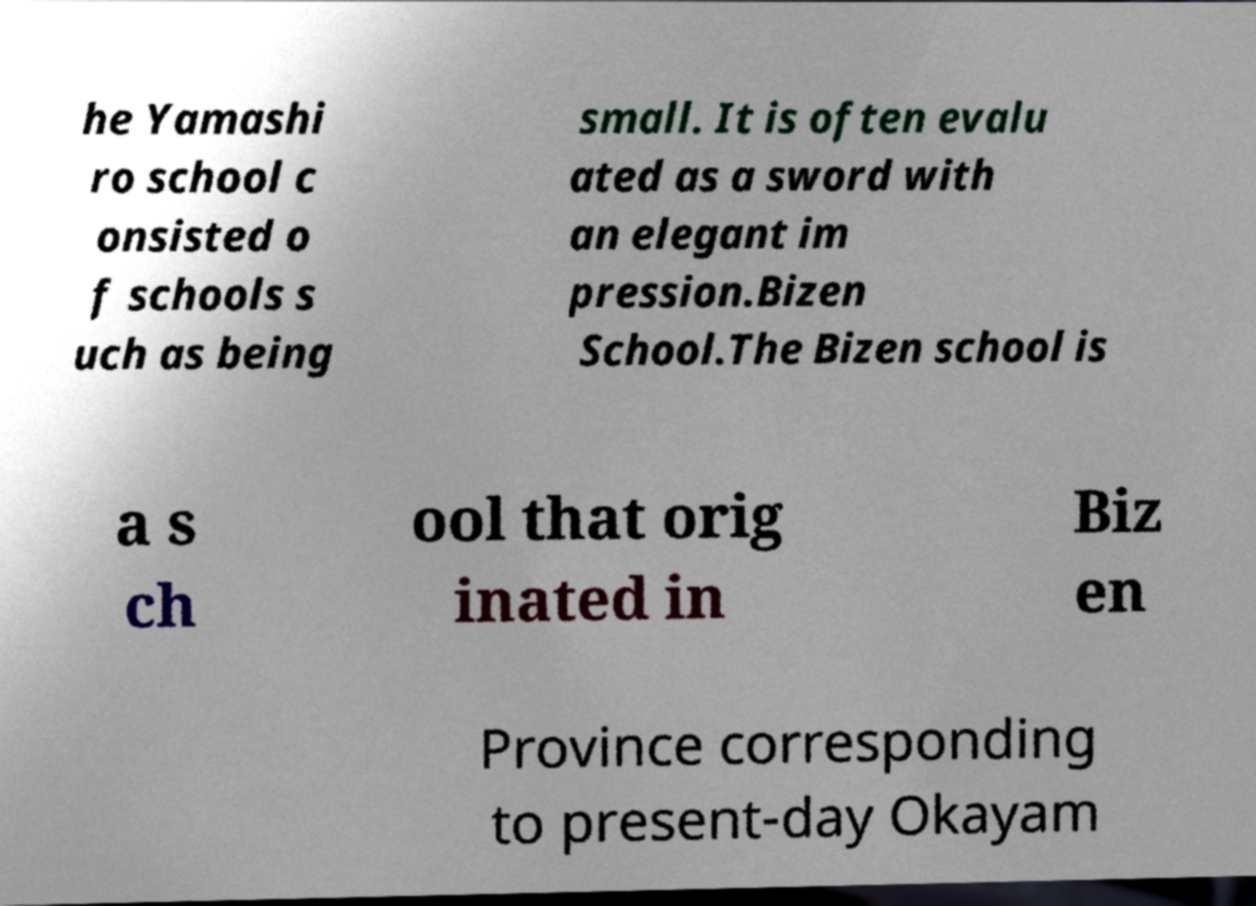There's text embedded in this image that I need extracted. Can you transcribe it verbatim? he Yamashi ro school c onsisted o f schools s uch as being small. It is often evalu ated as a sword with an elegant im pression.Bizen School.The Bizen school is a s ch ool that orig inated in Biz en Province corresponding to present-day Okayam 